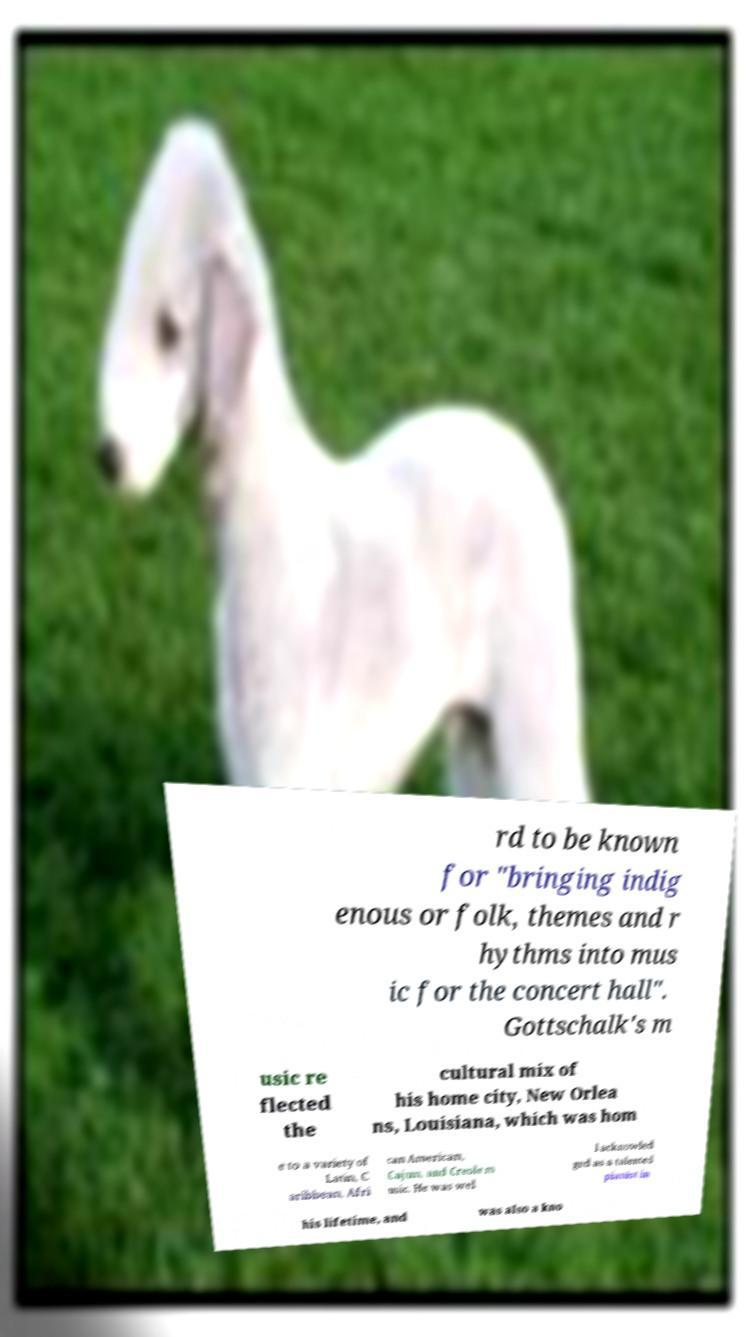I need the written content from this picture converted into text. Can you do that? rd to be known for "bringing indig enous or folk, themes and r hythms into mus ic for the concert hall". Gottschalk's m usic re flected the cultural mix of his home city, New Orlea ns, Louisiana, which was hom e to a variety of Latin, C aribbean, Afri can American, Cajun, and Creole m usic. He was wel l acknowled ged as a talented pianist in his lifetime, and was also a kno 